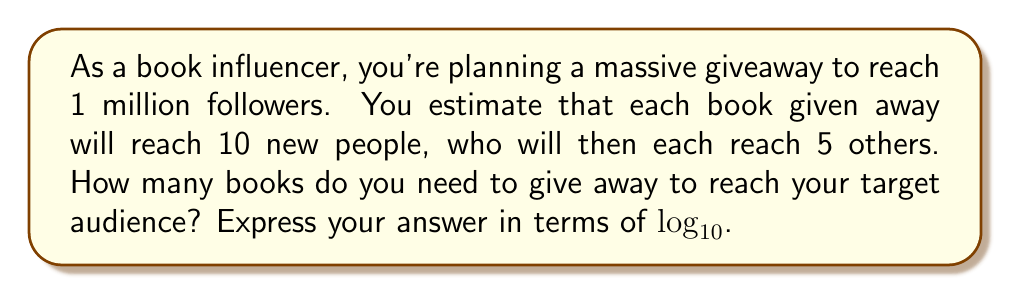Can you solve this math problem? Let's approach this step-by-step:

1) Let $x$ be the number of books we need to give away.

2) Each book reaches 10 new people directly, so $10x$ people are reached in the first round.

3) Each of these $10x$ people reaches 5 others, so $5(10x) = 50x$ additional people are reached in the second round.

4) The total reach is therefore $x + 10x + 50x = 61x$ people.

5) We want this to equal 1 million:

   $61x = 1,000,000$

6) Divide both sides by 61:

   $x = \frac{1,000,000}{61}$

7) To express this in terms of $\log_{10}$, we can write:

   $x = 10^{\log_{10}(\frac{1,000,000}{61})}$

8) Simplify inside the logarithm:

   $x = 10^{\log_{10}(16393.4426...)}$

9) The exact value is irrational, so we leave it in logarithmic form.
Answer: $10^{\log_{10}(\frac{1,000,000}{61})}$ books 